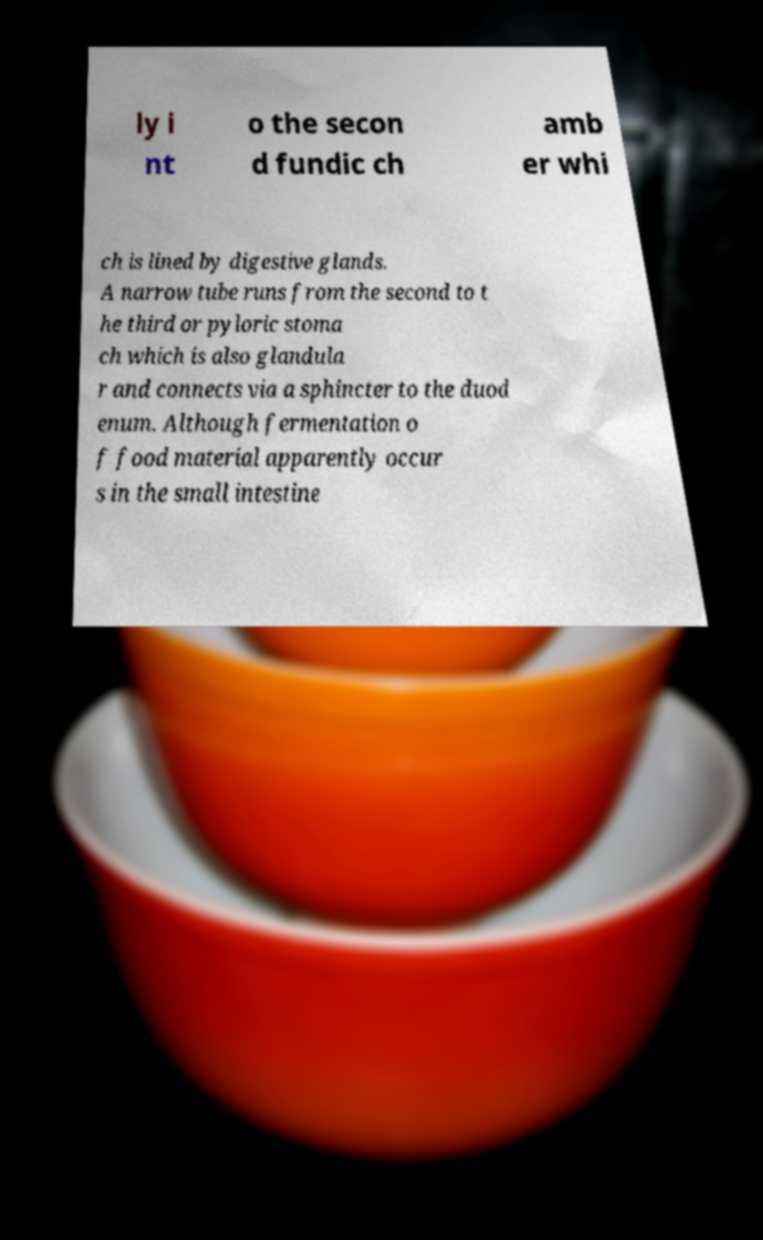Please identify and transcribe the text found in this image. ly i nt o the secon d fundic ch amb er whi ch is lined by digestive glands. A narrow tube runs from the second to t he third or pyloric stoma ch which is also glandula r and connects via a sphincter to the duod enum. Although fermentation o f food material apparently occur s in the small intestine 